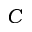<formula> <loc_0><loc_0><loc_500><loc_500>C</formula> 